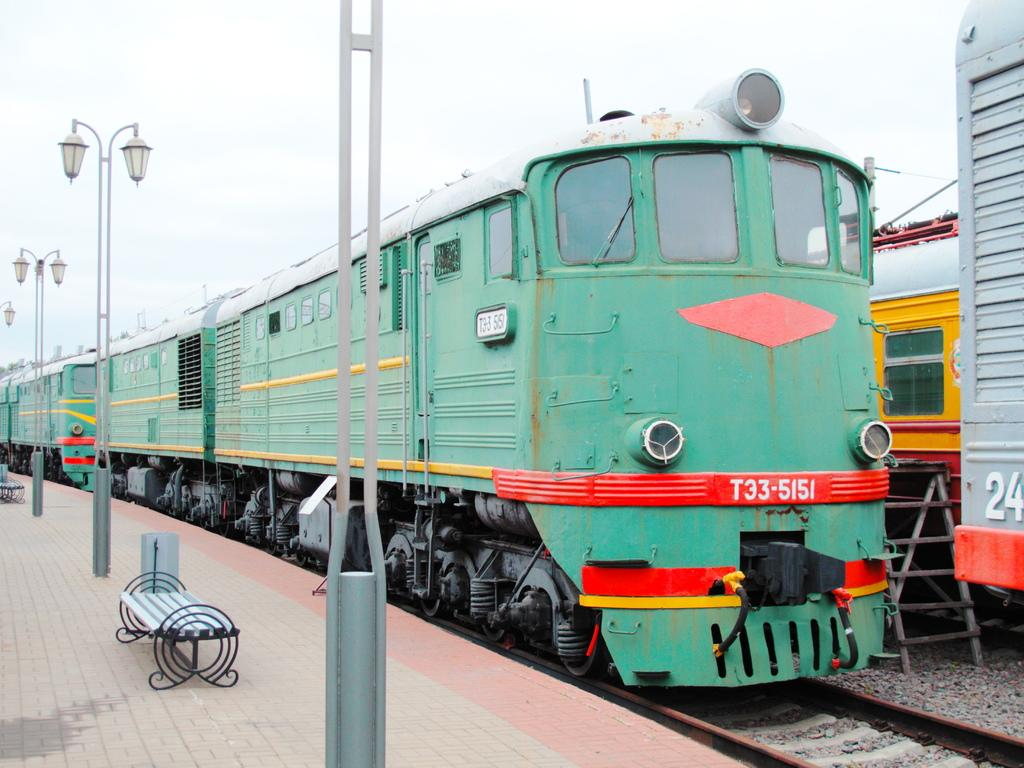<image>
Relay a brief, clear account of the picture shown. A large green train with the labeling T33-5151 sits on a track. 